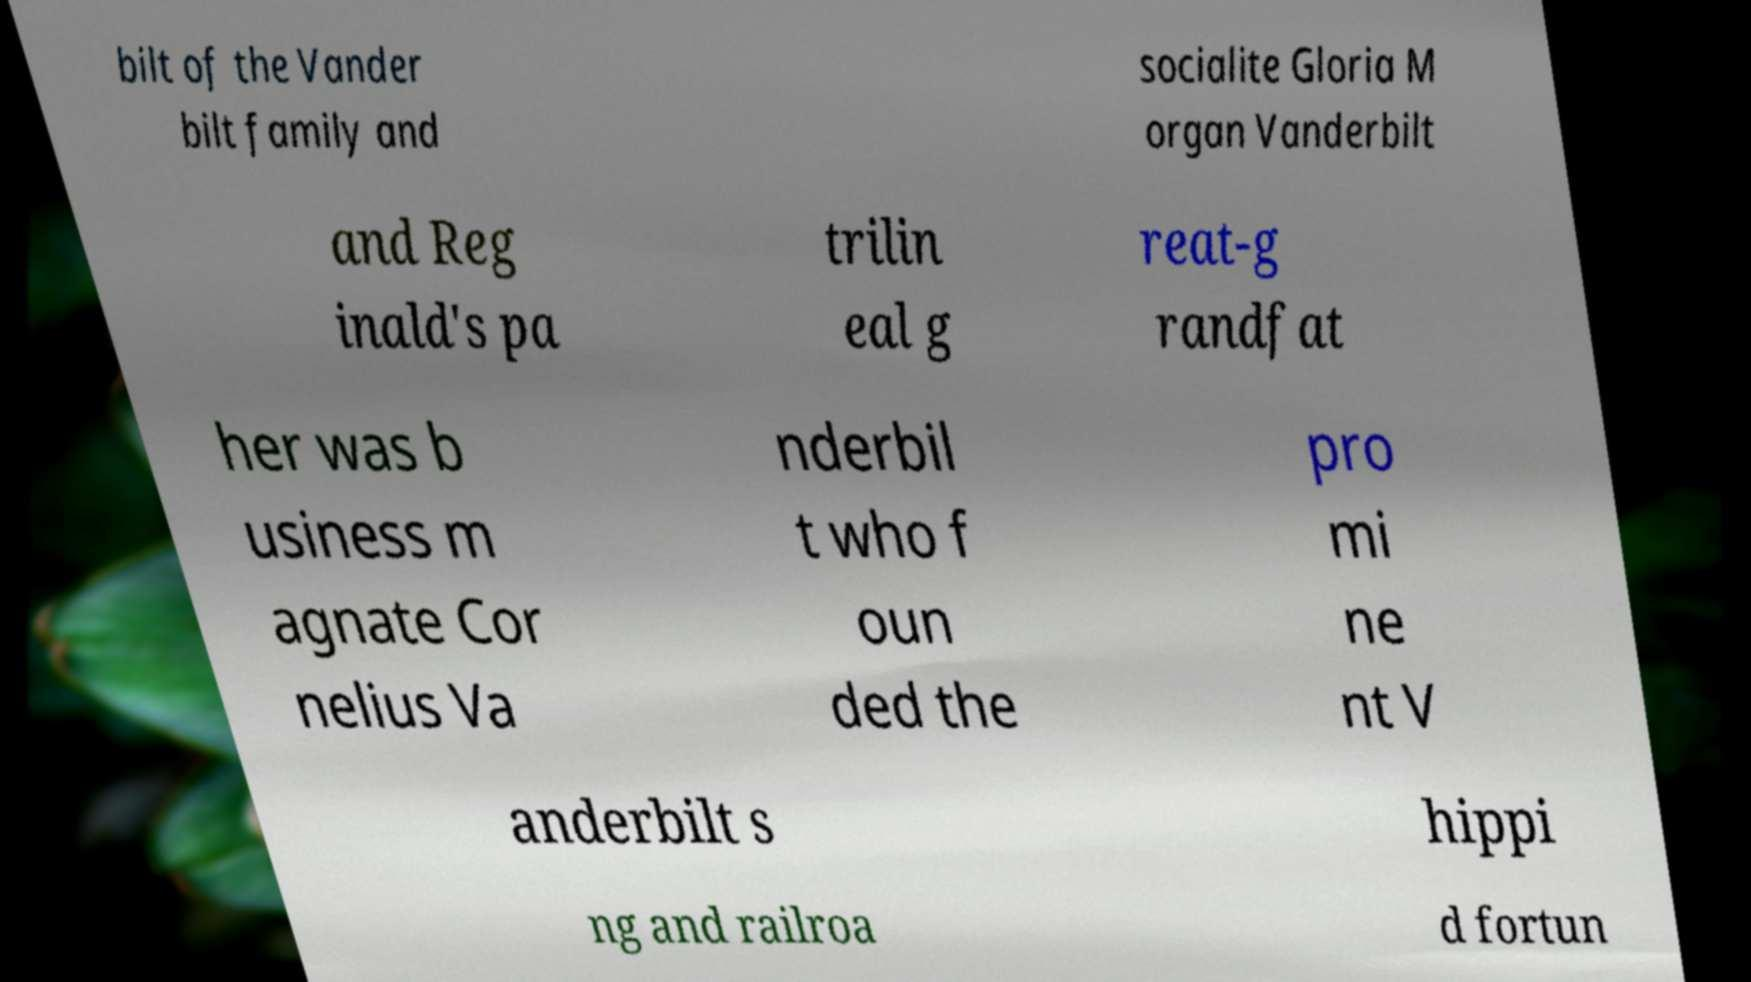Could you assist in decoding the text presented in this image and type it out clearly? bilt of the Vander bilt family and socialite Gloria M organ Vanderbilt and Reg inald's pa trilin eal g reat-g randfat her was b usiness m agnate Cor nelius Va nderbil t who f oun ded the pro mi ne nt V anderbilt s hippi ng and railroa d fortun 